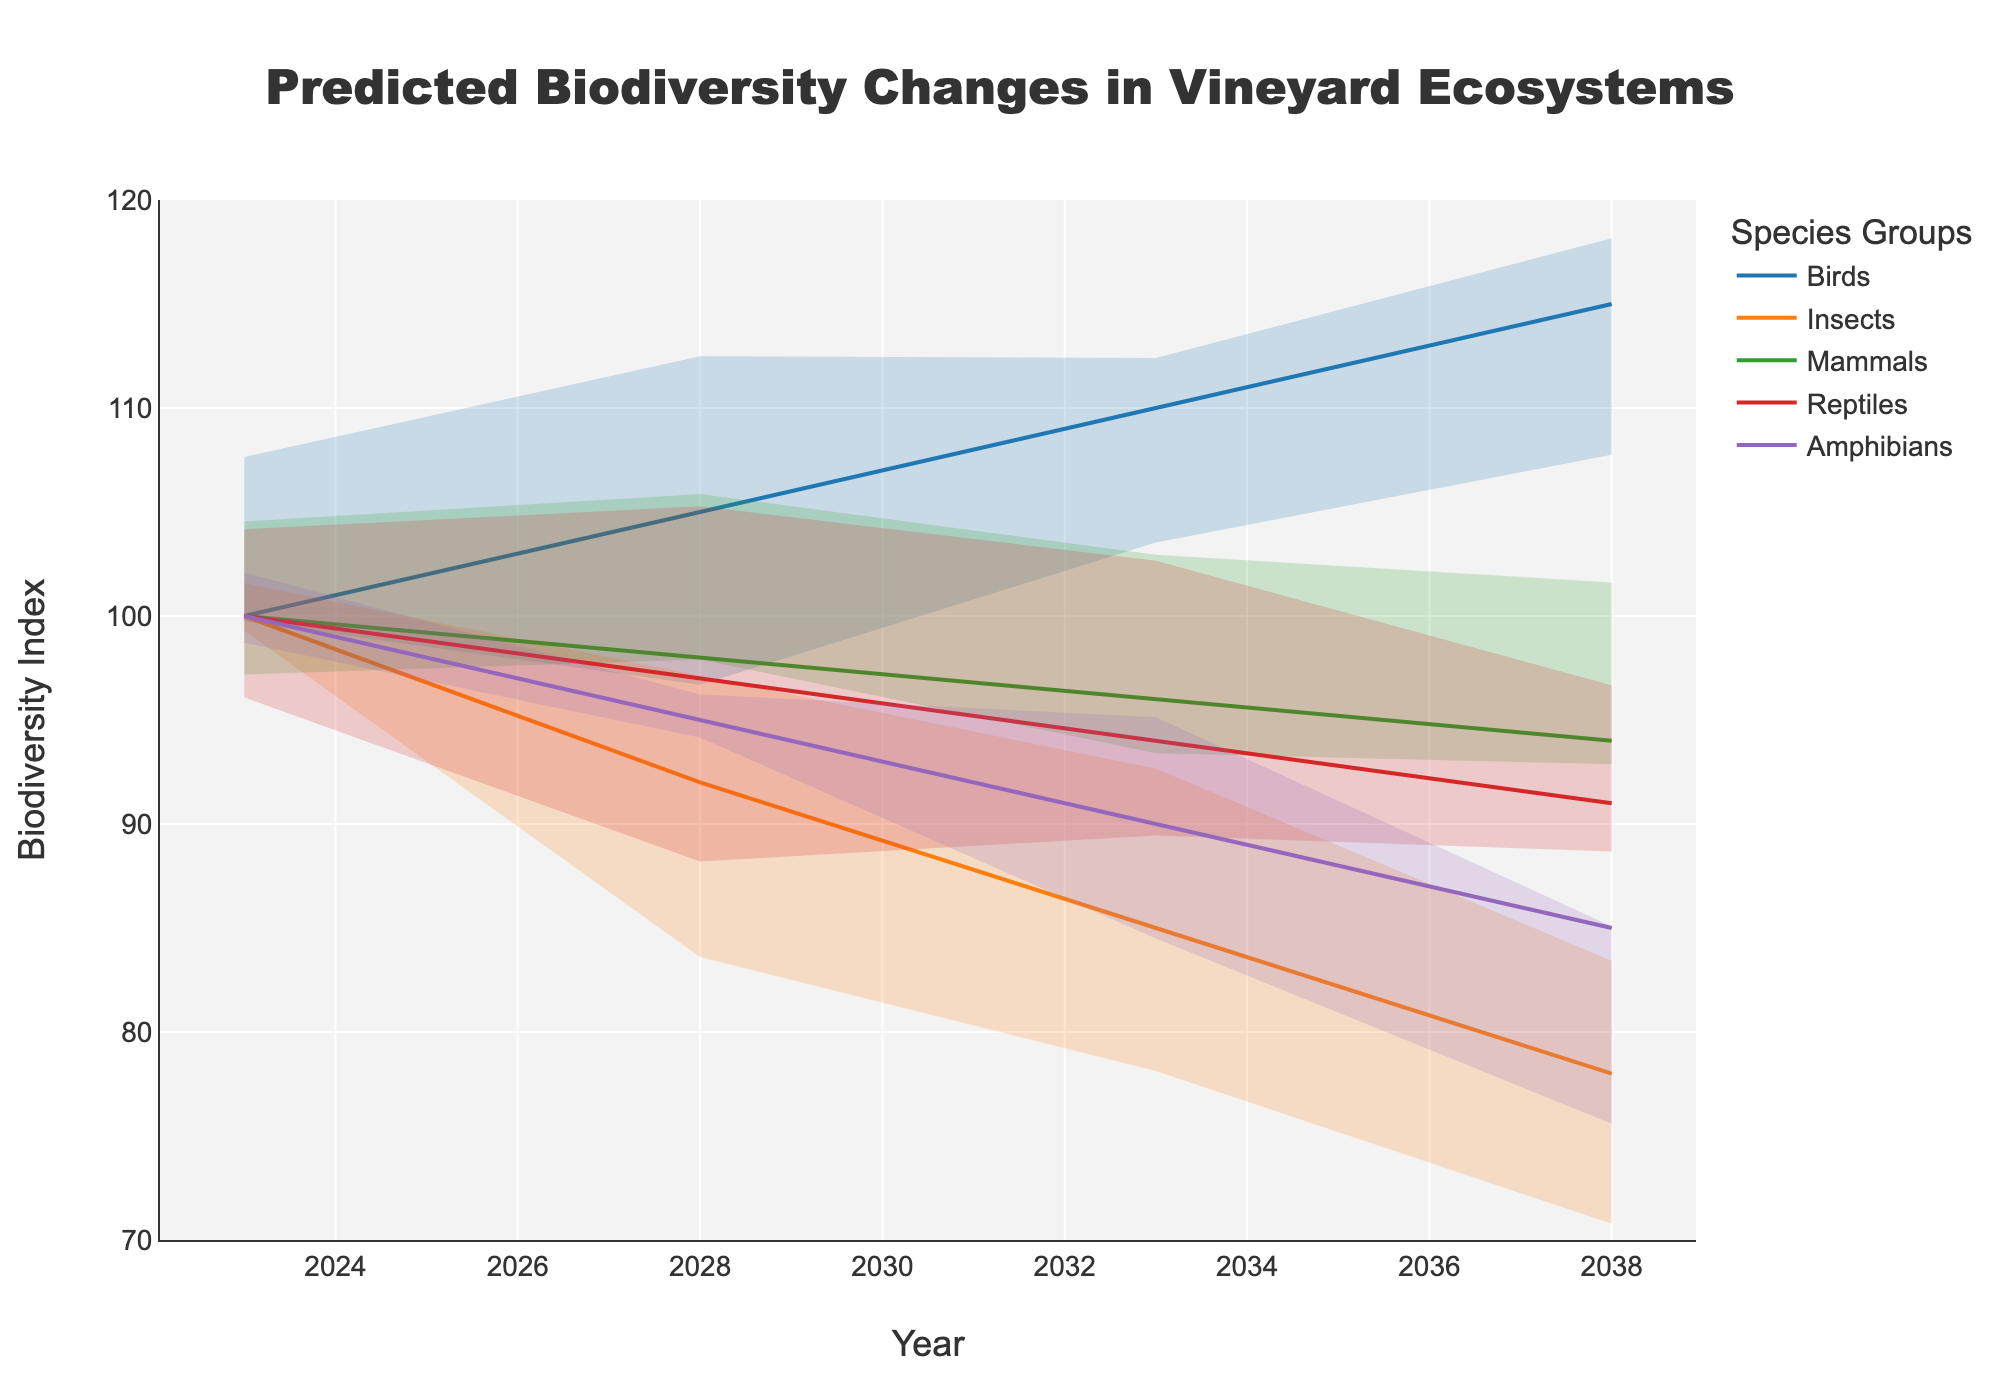How many species groups are included in the plot? There are 5 species groups visible in the plot, which can be identified by examining the legend. The groups are Birds, Insects, Mammals, Reptiles, and Amphibians.
Answer: 5 Which species group starts with the highest biodiversity index in 2023? Looking at the data points for the year 2023, the plot indicates that Birds have the highest starting biodiversity index of 100.
Answer: Birds What is the trend for the biodiversity index of Reptiles over the 15 years? Observing the series representing Reptiles from 2023 to 2038, the index shows a downward trend. The index starts at 100 in 2023, it decreases to 97 by 2028, 94 by 2033, and 91 by 2038.
Answer: Downward Which species group shows the most significant decrease in biodiversity index by 2038? Compare the biodiversity index in 2023 and 2038 for all species groups: Birds (100 to 115), Insects (100 to 78), Mammals (100 to 94), Reptiles (100 to 91), and Amphibians (100 to 85). Insects show the largest decrease from 100 to 78.
Answer: Insects Are there any species groups that have an increasing trend over the 15 years? By reviewing the index lines for each species group, only Birds exhibit an increasing trend from 100 in 2023 to 115 in 2038.
Answer: Birds What is the average biodiversity index for mammals from 2023 to 2038? The biodiversity indices for mammals are 100 (2023), 98 (2028), 96 (2033), and 94 (2038). To find the average: (100 + 98 + 96 + 94) / 4 = 97.
Answer: 97 Which species group has the least variability (uncertainty area) in its indices over the period? Reviewing the uncertainty areas for each species group, Birds have the narrowest area, indicating the least variability.
Answer: Birds For the year 2028, which species group has the lowest biodiversity index? By examining the index points for 2028, Insects have the lowest biodiversity index at 92 among all groups.
Answer: Insects What is the difference in biodiversity index for Amphibians between 2023 and 2038? The biodiversity index for Amphibians is 100 in 2023 and 85 in 2038. The difference is calculated as 100 - 85 = 15.
Answer: 15 